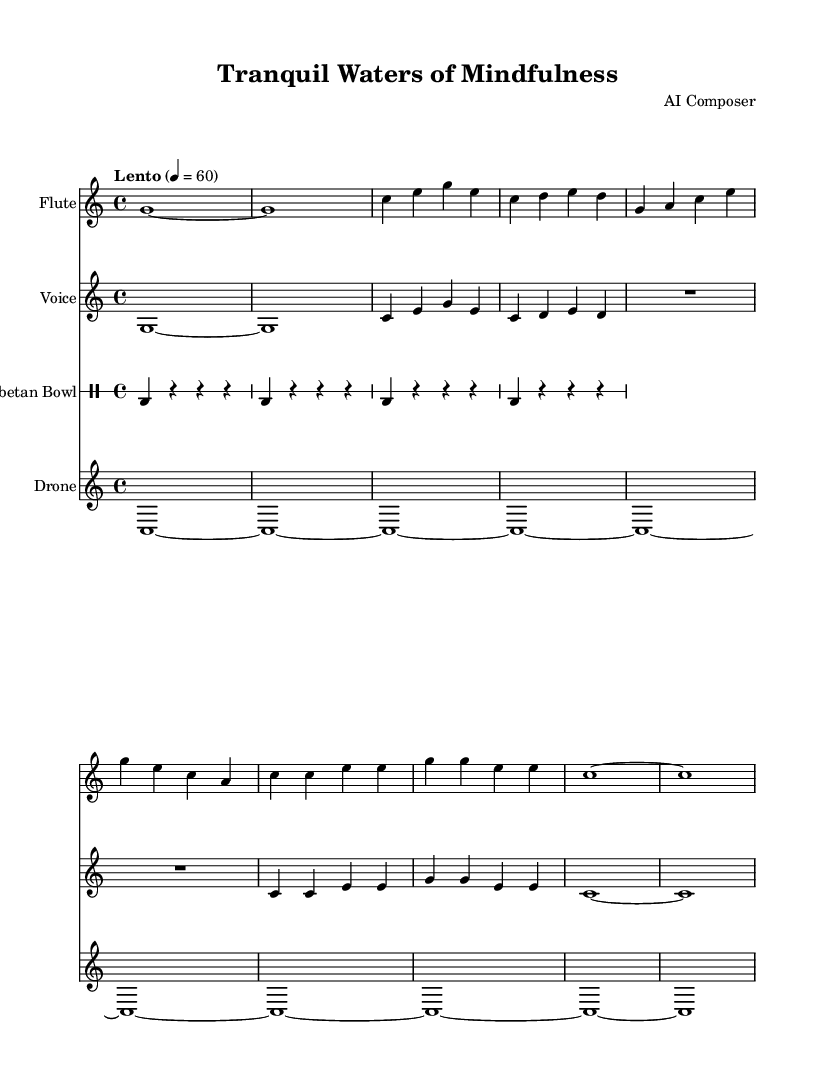What is the key signature of this music? The key signature is C major, which has no sharps or flats indicated in the music. This can be identified by looking at the beginning of the staff where the key signature is noted.
Answer: C major What is the time signature of this music? The time signature is found at the start of the score and it is 4/4, meaning there are four beats in each measure and the quarter note receives one beat.
Answer: 4/4 What is the tempo marking of the piece? The tempo marking "Lento" indicates a slow pace, and the specific beat indication of 4 = 60 indicates that there are 60 beats per minute.
Answer: Lento How many staves are present in the score? By counting the notated staves in the music, which include those for flute, voice, Tibetan bowl, and drone, we find a total of four staves present in the score.
Answer: Four What are the lyrics for Chant A? The lyrics for Chant A are indicated under the corresponding music notation, which is "Om ma -- ni pad -- me hum” based on the lyrics assigned to the voice part.
Answer: Om ma -- ni pad -- me hum Which instrument maintains a continuous sound throughout the piece? The drone part, which is indicated in the score, plays a continuous pitch, providing a harmonic foundation for the other instruments.
Answer: Drone 